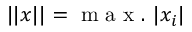<formula> <loc_0><loc_0><loc_500><loc_500>| | x | | = m a x . | x _ { i } |</formula> 